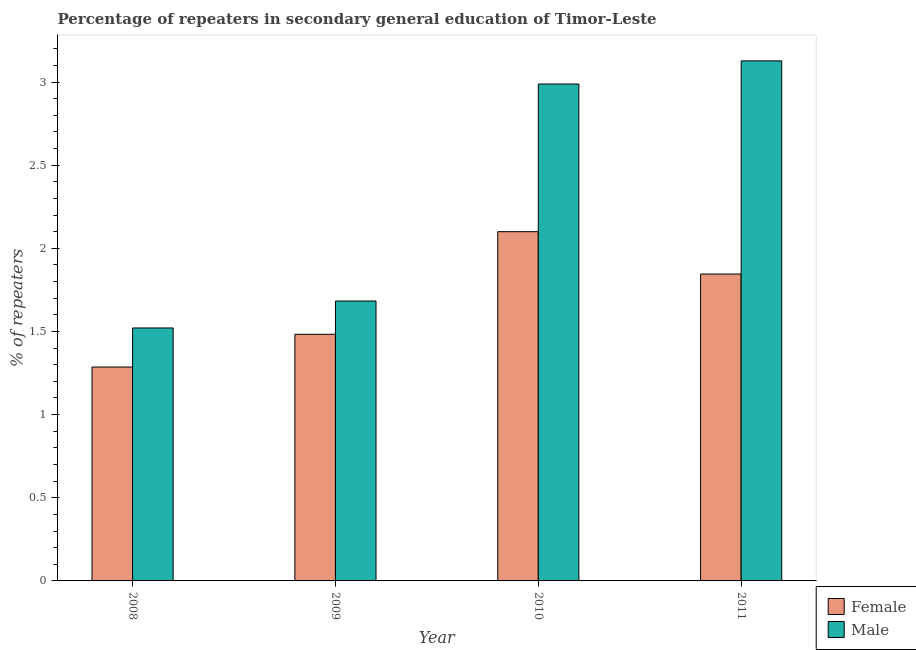Are the number of bars per tick equal to the number of legend labels?
Provide a succinct answer. Yes. Are the number of bars on each tick of the X-axis equal?
Your answer should be very brief. Yes. How many bars are there on the 4th tick from the left?
Offer a terse response. 2. How many bars are there on the 3rd tick from the right?
Provide a short and direct response. 2. What is the percentage of female repeaters in 2008?
Your answer should be very brief. 1.29. Across all years, what is the maximum percentage of male repeaters?
Offer a very short reply. 3.13. Across all years, what is the minimum percentage of female repeaters?
Provide a succinct answer. 1.29. What is the total percentage of female repeaters in the graph?
Keep it short and to the point. 6.71. What is the difference between the percentage of female repeaters in 2008 and that in 2011?
Offer a very short reply. -0.56. What is the difference between the percentage of female repeaters in 2011 and the percentage of male repeaters in 2009?
Provide a succinct answer. 0.36. What is the average percentage of male repeaters per year?
Your answer should be compact. 2.33. In the year 2011, what is the difference between the percentage of male repeaters and percentage of female repeaters?
Keep it short and to the point. 0. In how many years, is the percentage of female repeaters greater than 0.2 %?
Ensure brevity in your answer.  4. What is the ratio of the percentage of female repeaters in 2008 to that in 2011?
Offer a very short reply. 0.7. Is the percentage of male repeaters in 2009 less than that in 2011?
Your answer should be very brief. Yes. What is the difference between the highest and the second highest percentage of male repeaters?
Give a very brief answer. 0.14. What is the difference between the highest and the lowest percentage of male repeaters?
Offer a very short reply. 1.61. Is the sum of the percentage of male repeaters in 2008 and 2011 greater than the maximum percentage of female repeaters across all years?
Provide a short and direct response. Yes. What does the 2nd bar from the left in 2009 represents?
Offer a very short reply. Male. What does the 1st bar from the right in 2011 represents?
Provide a succinct answer. Male. How many bars are there?
Keep it short and to the point. 8. Are the values on the major ticks of Y-axis written in scientific E-notation?
Offer a terse response. No. How are the legend labels stacked?
Give a very brief answer. Vertical. What is the title of the graph?
Provide a short and direct response. Percentage of repeaters in secondary general education of Timor-Leste. Does "Working capital" appear as one of the legend labels in the graph?
Give a very brief answer. No. What is the label or title of the Y-axis?
Your answer should be very brief. % of repeaters. What is the % of repeaters of Female in 2008?
Provide a short and direct response. 1.29. What is the % of repeaters in Male in 2008?
Offer a very short reply. 1.52. What is the % of repeaters in Female in 2009?
Ensure brevity in your answer.  1.48. What is the % of repeaters in Male in 2009?
Your answer should be compact. 1.68. What is the % of repeaters of Female in 2010?
Keep it short and to the point. 2.1. What is the % of repeaters of Male in 2010?
Your answer should be very brief. 2.99. What is the % of repeaters in Female in 2011?
Provide a short and direct response. 1.85. What is the % of repeaters of Male in 2011?
Provide a short and direct response. 3.13. Across all years, what is the maximum % of repeaters in Female?
Keep it short and to the point. 2.1. Across all years, what is the maximum % of repeaters in Male?
Offer a terse response. 3.13. Across all years, what is the minimum % of repeaters of Female?
Provide a short and direct response. 1.29. Across all years, what is the minimum % of repeaters of Male?
Ensure brevity in your answer.  1.52. What is the total % of repeaters in Female in the graph?
Offer a very short reply. 6.71. What is the total % of repeaters of Male in the graph?
Provide a succinct answer. 9.32. What is the difference between the % of repeaters in Female in 2008 and that in 2009?
Provide a succinct answer. -0.2. What is the difference between the % of repeaters of Male in 2008 and that in 2009?
Your answer should be compact. -0.16. What is the difference between the % of repeaters in Female in 2008 and that in 2010?
Ensure brevity in your answer.  -0.81. What is the difference between the % of repeaters of Male in 2008 and that in 2010?
Give a very brief answer. -1.47. What is the difference between the % of repeaters in Female in 2008 and that in 2011?
Your response must be concise. -0.56. What is the difference between the % of repeaters of Male in 2008 and that in 2011?
Your answer should be compact. -1.61. What is the difference between the % of repeaters in Female in 2009 and that in 2010?
Your response must be concise. -0.62. What is the difference between the % of repeaters of Male in 2009 and that in 2010?
Offer a terse response. -1.3. What is the difference between the % of repeaters of Female in 2009 and that in 2011?
Offer a terse response. -0.36. What is the difference between the % of repeaters of Male in 2009 and that in 2011?
Your answer should be very brief. -1.44. What is the difference between the % of repeaters in Female in 2010 and that in 2011?
Make the answer very short. 0.25. What is the difference between the % of repeaters of Male in 2010 and that in 2011?
Keep it short and to the point. -0.14. What is the difference between the % of repeaters of Female in 2008 and the % of repeaters of Male in 2009?
Offer a terse response. -0.4. What is the difference between the % of repeaters in Female in 2008 and the % of repeaters in Male in 2010?
Your answer should be very brief. -1.7. What is the difference between the % of repeaters in Female in 2008 and the % of repeaters in Male in 2011?
Keep it short and to the point. -1.84. What is the difference between the % of repeaters of Female in 2009 and the % of repeaters of Male in 2010?
Provide a succinct answer. -1.5. What is the difference between the % of repeaters in Female in 2009 and the % of repeaters in Male in 2011?
Provide a short and direct response. -1.64. What is the difference between the % of repeaters in Female in 2010 and the % of repeaters in Male in 2011?
Provide a short and direct response. -1.03. What is the average % of repeaters of Female per year?
Ensure brevity in your answer.  1.68. What is the average % of repeaters in Male per year?
Offer a very short reply. 2.33. In the year 2008, what is the difference between the % of repeaters in Female and % of repeaters in Male?
Offer a terse response. -0.23. In the year 2009, what is the difference between the % of repeaters of Female and % of repeaters of Male?
Keep it short and to the point. -0.2. In the year 2010, what is the difference between the % of repeaters of Female and % of repeaters of Male?
Ensure brevity in your answer.  -0.89. In the year 2011, what is the difference between the % of repeaters in Female and % of repeaters in Male?
Offer a very short reply. -1.28. What is the ratio of the % of repeaters in Female in 2008 to that in 2009?
Provide a succinct answer. 0.87. What is the ratio of the % of repeaters in Male in 2008 to that in 2009?
Provide a short and direct response. 0.9. What is the ratio of the % of repeaters of Female in 2008 to that in 2010?
Ensure brevity in your answer.  0.61. What is the ratio of the % of repeaters in Male in 2008 to that in 2010?
Your response must be concise. 0.51. What is the ratio of the % of repeaters of Female in 2008 to that in 2011?
Offer a terse response. 0.7. What is the ratio of the % of repeaters of Male in 2008 to that in 2011?
Your response must be concise. 0.49. What is the ratio of the % of repeaters of Female in 2009 to that in 2010?
Your answer should be very brief. 0.71. What is the ratio of the % of repeaters of Male in 2009 to that in 2010?
Ensure brevity in your answer.  0.56. What is the ratio of the % of repeaters of Female in 2009 to that in 2011?
Offer a very short reply. 0.8. What is the ratio of the % of repeaters in Male in 2009 to that in 2011?
Offer a very short reply. 0.54. What is the ratio of the % of repeaters in Female in 2010 to that in 2011?
Provide a short and direct response. 1.14. What is the ratio of the % of repeaters of Male in 2010 to that in 2011?
Keep it short and to the point. 0.96. What is the difference between the highest and the second highest % of repeaters of Female?
Ensure brevity in your answer.  0.25. What is the difference between the highest and the second highest % of repeaters of Male?
Offer a terse response. 0.14. What is the difference between the highest and the lowest % of repeaters of Female?
Ensure brevity in your answer.  0.81. What is the difference between the highest and the lowest % of repeaters of Male?
Make the answer very short. 1.61. 